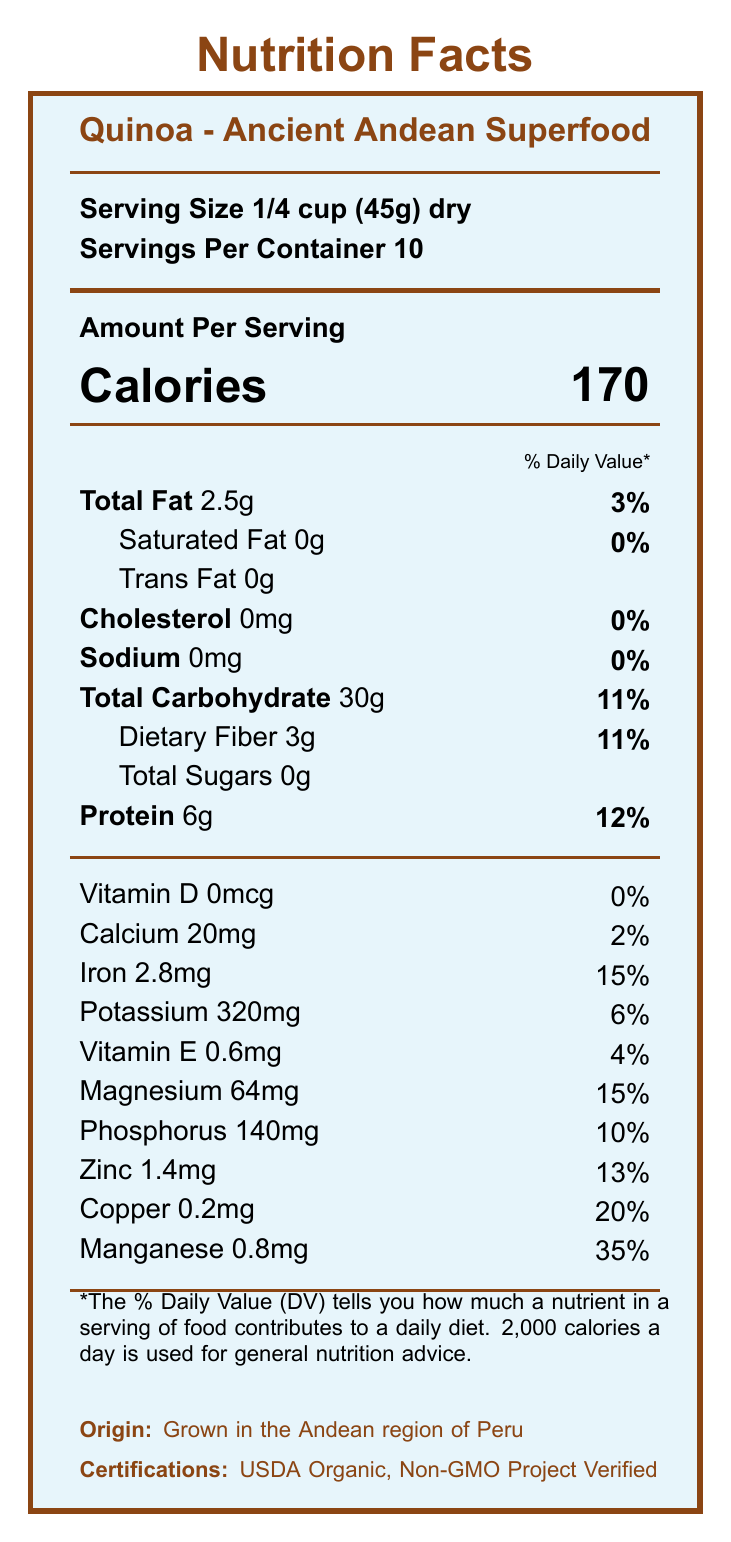what is the serving size? The serving size is mentioned at the beginning of the document as "Serving Size 1/4 cup (45g) dry".
Answer: 1/4 cup (45g) dry how many servings are in the container? The document states "Servings Per Container 10".
Answer: 10 how many calories are in one serving? Under the "Amount Per Serving" section, it lists "Calories 170".
Answer: 170 what is the daily value percentage of total fat? The document lists "Total Fat 2.5g" with a daily value percentage of "3%".
Answer: 3% how much protein does one serving contain? It is mentioned under "Protein" that one serving contains "6g" of protein with a daily value percentage of "12%".
Answer: 6g how much sodium is in one serving? The document states "Sodium 0mg" with a daily value percentage of "0%".
Answer: 0mg what is the origin of the Quinoa? At the bottom of the document, it states "Origin: Grown in the Andean region of Peru".
Answer: Grown in the Andean region of Peru which vitamin or mineral has the highest daily value percentage? A. Vitamin D B. Iron C. Manganese D. Zinc Manganese has a daily value percentage of "35%", which is higher than the others listed.
Answer: C. Manganese how many grams of dietary fiber are in each serving of quinoa? According to the document, each serving contains "Dietary Fiber 3g" with a daily value percentage of "11%".
Answer: 3g what is the daily value percentage of magnesium? A. 2% B. 10% C. 15% D. 20% The document lists "Magnesium 64mg/15%" under the nutrition facts.
Answer: C. 15% is this product certified organic? The bottom of the document lists certifications including "USDA Organic".
Answer: Yes does the quinoa contain any saturated fat? The document states "Saturated Fat 0g" with a daily value percentage of "0%".
Answer: No describe the main idea of the document The document provides a comprehensive overview of the nutritional content and health benefits of Quinoa, along with preparation instructions, origin details, and certifications.
Answer: The document provides detailed nutrition facts about Quinoa - an ancient Andean superfood. It lists the serving size, number of servings per container, calorie content, and various nutrients with their respective amounts and daily values. It also includes the product's origin, certifications, and some nutritional and health benefits. how many calories come from fats in one serving? The document does not provide information on the number of calories specifically coming from fats.
Answer: Cannot be determined is quinoa gluten-free? The additional information section states "Naturally gluten-free and easy to digest".
Answer: Yes how should quinoa be stored after opening? The storage instructions mention "After opening, store in an airtight container."
Answer: In an airtight container 